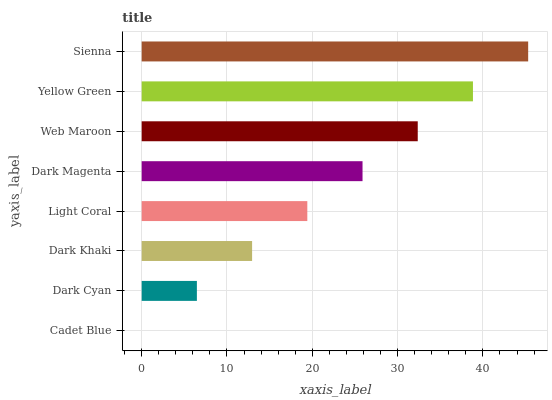Is Cadet Blue the minimum?
Answer yes or no. Yes. Is Sienna the maximum?
Answer yes or no. Yes. Is Dark Cyan the minimum?
Answer yes or no. No. Is Dark Cyan the maximum?
Answer yes or no. No. Is Dark Cyan greater than Cadet Blue?
Answer yes or no. Yes. Is Cadet Blue less than Dark Cyan?
Answer yes or no. Yes. Is Cadet Blue greater than Dark Cyan?
Answer yes or no. No. Is Dark Cyan less than Cadet Blue?
Answer yes or no. No. Is Dark Magenta the high median?
Answer yes or no. Yes. Is Light Coral the low median?
Answer yes or no. Yes. Is Dark Cyan the high median?
Answer yes or no. No. Is Sienna the low median?
Answer yes or no. No. 